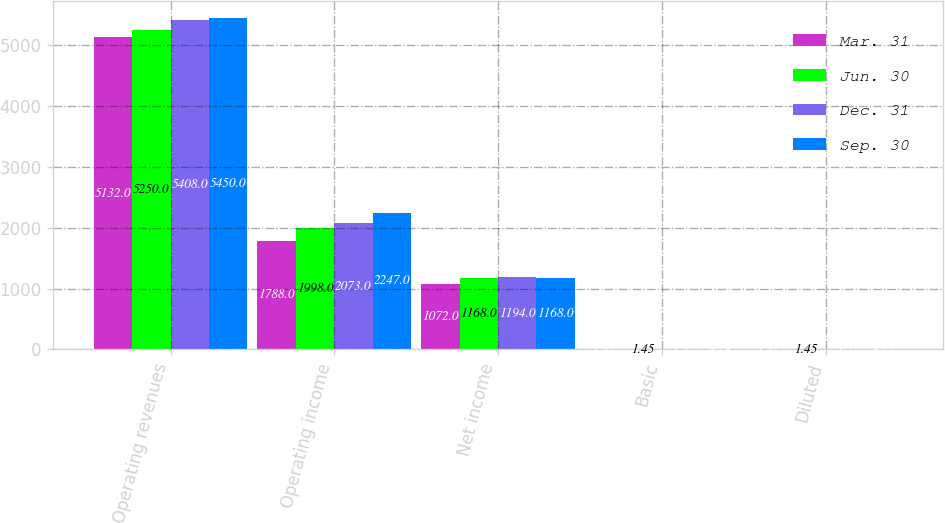Convert chart. <chart><loc_0><loc_0><loc_500><loc_500><stacked_bar_chart><ecel><fcel>Operating revenues<fcel>Operating income<fcel>Net income<fcel>Basic<fcel>Diluted<nl><fcel>Mar. 31<fcel>5132<fcel>1788<fcel>1072<fcel>1.32<fcel>1.32<nl><fcel>Jun. 30<fcel>5250<fcel>1998<fcel>1168<fcel>1.45<fcel>1.45<nl><fcel>Dec. 31<fcel>5408<fcel>2073<fcel>1194<fcel>1.5<fcel>1.5<nl><fcel>Sep. 30<fcel>5450<fcel>2247<fcel>1168<fcel>9.29<fcel>9.25<nl></chart> 